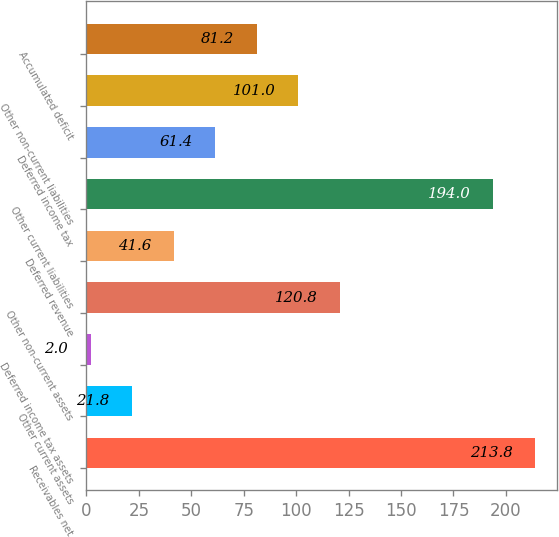<chart> <loc_0><loc_0><loc_500><loc_500><bar_chart><fcel>Receivables net<fcel>Other current assets<fcel>Deferred income tax assets<fcel>Other non-current assets<fcel>Deferred revenue<fcel>Other current liabilities<fcel>Deferred income tax<fcel>Other non-current liabilities<fcel>Accumulated deficit<nl><fcel>213.8<fcel>21.8<fcel>2<fcel>120.8<fcel>41.6<fcel>194<fcel>61.4<fcel>101<fcel>81.2<nl></chart> 